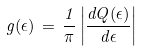<formula> <loc_0><loc_0><loc_500><loc_500>g ( \epsilon ) \, = \, \frac { 1 } { \pi } \left | \frac { d Q ( \epsilon ) } { d \epsilon } \right |</formula> 